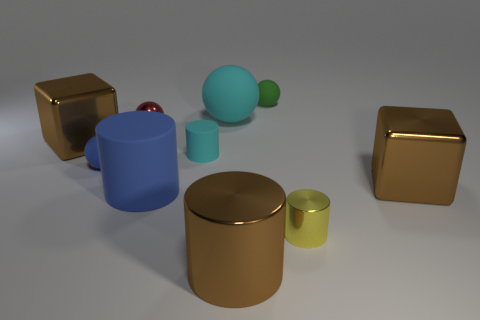Is the size of the shiny ball the same as the cube on the left side of the small green matte thing? The shiny ball is slightly smaller than the cube on the left side of the small green matte object. The ball's reflective surface can make size comparison tricky at first glance, but after careful observation, the cube appears to have a slightly larger volume. 